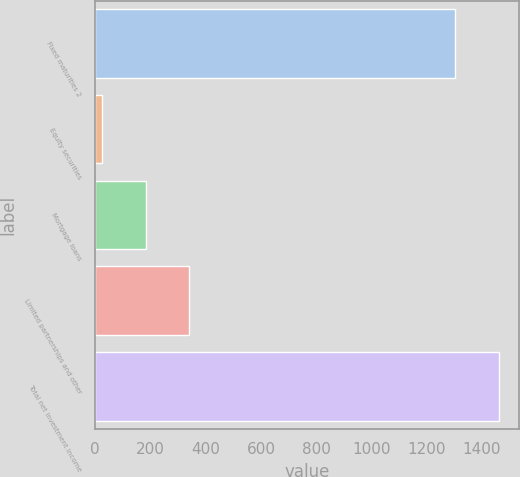<chart> <loc_0><loc_0><loc_500><loc_500><bar_chart><fcel>Fixed maturities 2<fcel>Equity securities<fcel>Mortgage loans<fcel>Limited partnerships and other<fcel>Total net investment income<nl><fcel>1303<fcel>24<fcel>181.9<fcel>339.8<fcel>1460.9<nl></chart> 